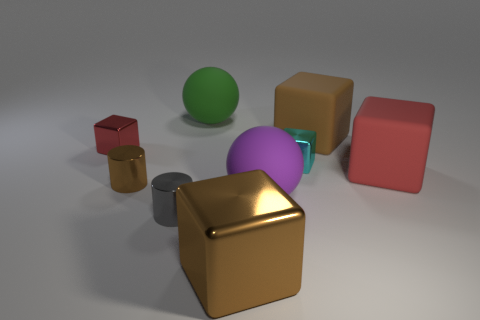Subtract all red cubes. How many cubes are left? 3 Subtract all small blocks. How many blocks are left? 3 Subtract all purple blocks. Subtract all red cylinders. How many blocks are left? 5 Add 1 large yellow cylinders. How many objects exist? 10 Subtract all balls. How many objects are left? 7 Subtract all yellow cylinders. Subtract all cylinders. How many objects are left? 7 Add 9 large brown metallic blocks. How many large brown metallic blocks are left? 10 Add 8 purple balls. How many purple balls exist? 9 Subtract 1 cyan cubes. How many objects are left? 8 